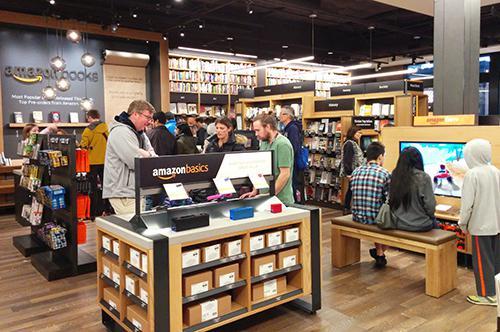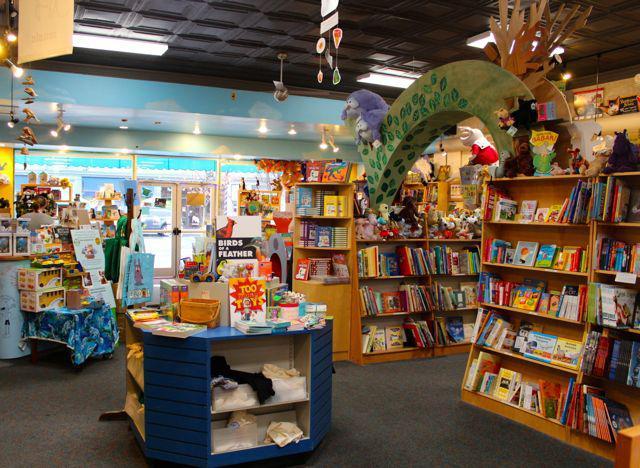The first image is the image on the left, the second image is the image on the right. Analyze the images presented: Is the assertion "There are no more than 3 people in the image on the left." valid? Answer yes or no. No. 